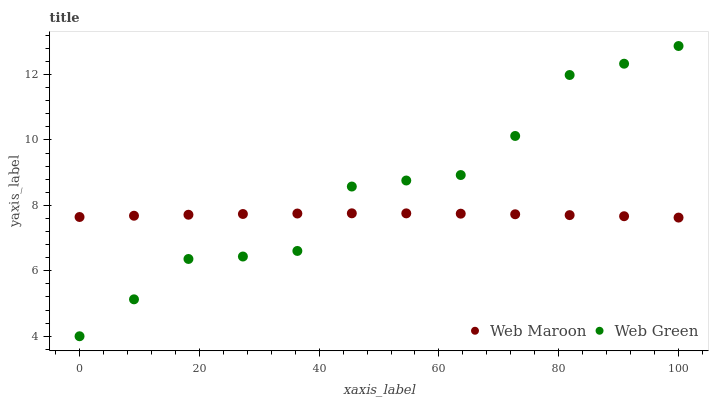Does Web Maroon have the minimum area under the curve?
Answer yes or no. Yes. Does Web Green have the maximum area under the curve?
Answer yes or no. Yes. Does Web Green have the minimum area under the curve?
Answer yes or no. No. Is Web Maroon the smoothest?
Answer yes or no. Yes. Is Web Green the roughest?
Answer yes or no. Yes. Is Web Green the smoothest?
Answer yes or no. No. Does Web Green have the lowest value?
Answer yes or no. Yes. Does Web Green have the highest value?
Answer yes or no. Yes. Does Web Green intersect Web Maroon?
Answer yes or no. Yes. Is Web Green less than Web Maroon?
Answer yes or no. No. Is Web Green greater than Web Maroon?
Answer yes or no. No. 